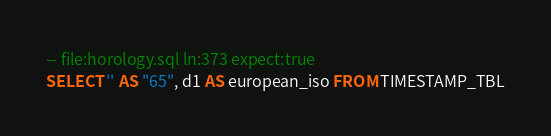Convert code to text. <code><loc_0><loc_0><loc_500><loc_500><_SQL_>-- file:horology.sql ln:373 expect:true
SELECT '' AS "65", d1 AS european_iso FROM TIMESTAMP_TBL
</code> 